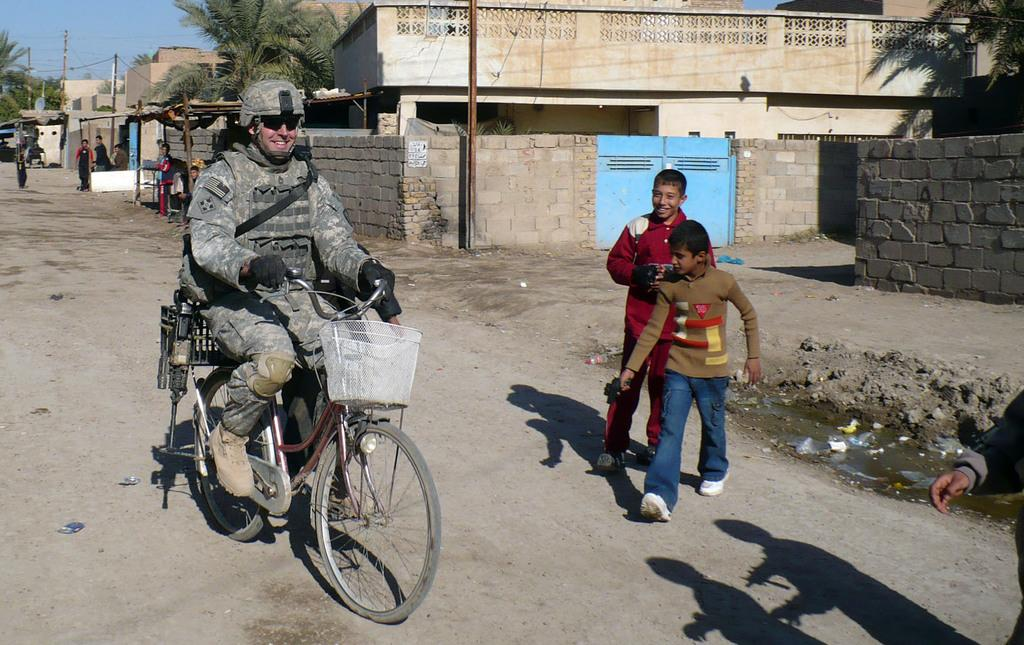What is the military person doing in the image? The military person is riding a bicycle in the image. What are the two boys doing in the image? The two boys are walking on the right side of the road are walking. What can be seen in the background of the image? There are trees, buildings, a pole, people, and the sky visible in the background of the image. What type of sofa can be seen in the image? There is no sofa present in the image. Is there a gate visible in the image? There is no gate visible in the image. Can you see a ship in the image? There is no ship visible in the image. 